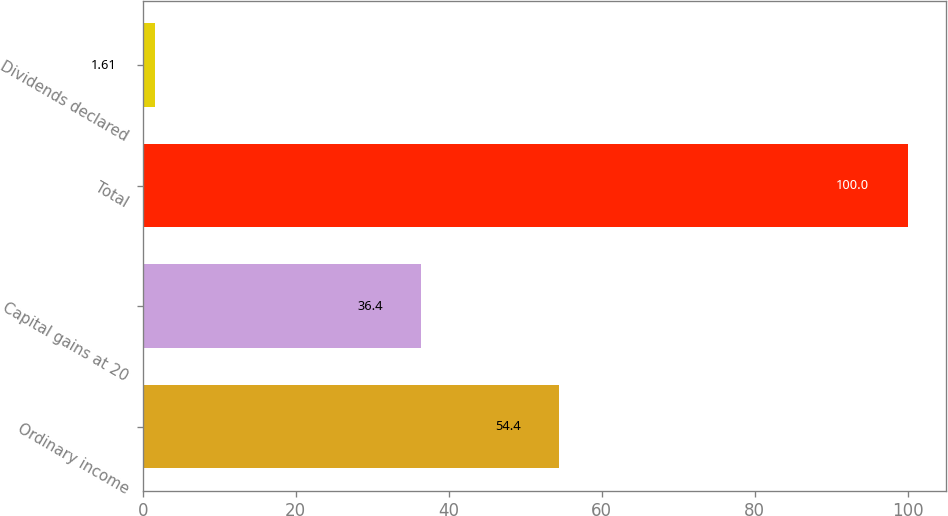Convert chart to OTSL. <chart><loc_0><loc_0><loc_500><loc_500><bar_chart><fcel>Ordinary income<fcel>Capital gains at 20<fcel>Total<fcel>Dividends declared<nl><fcel>54.4<fcel>36.4<fcel>100<fcel>1.61<nl></chart> 